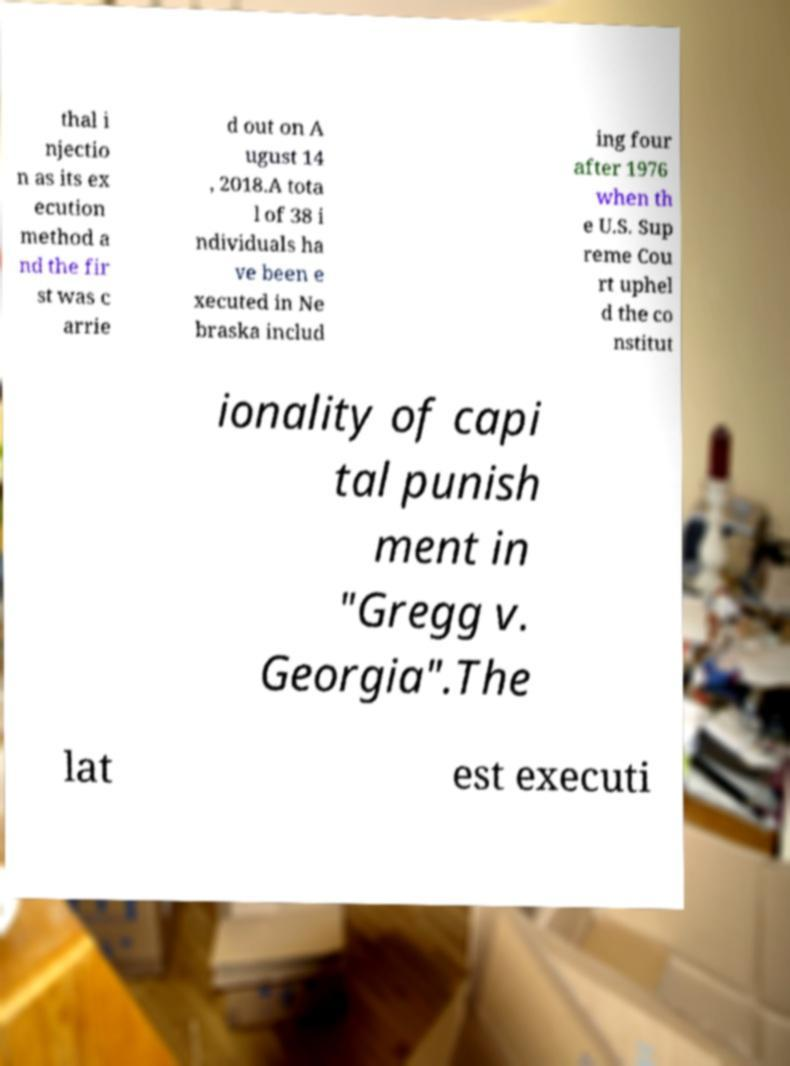I need the written content from this picture converted into text. Can you do that? thal i njectio n as its ex ecution method a nd the fir st was c arrie d out on A ugust 14 , 2018.A tota l of 38 i ndividuals ha ve been e xecuted in Ne braska includ ing four after 1976 when th e U.S. Sup reme Cou rt uphel d the co nstitut ionality of capi tal punish ment in "Gregg v. Georgia".The lat est executi 